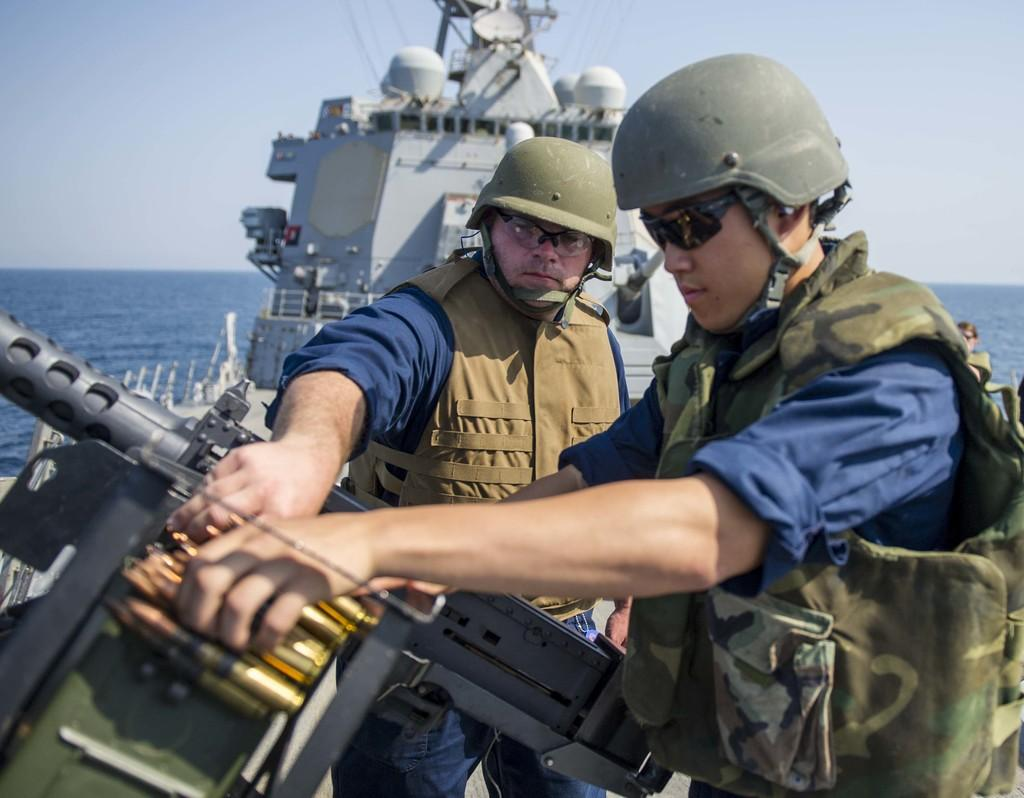How many people are in the ship in the image? There are two persons standing in the ship. What are the people near in the image? They are standing near a weapon. What can be seen in the background of the image? There is water and the sky visible in the background. What type of cable is being used to connect the ship to the shore in the image? There is no cable visible in the image, and the ship is not connected to the shore. 